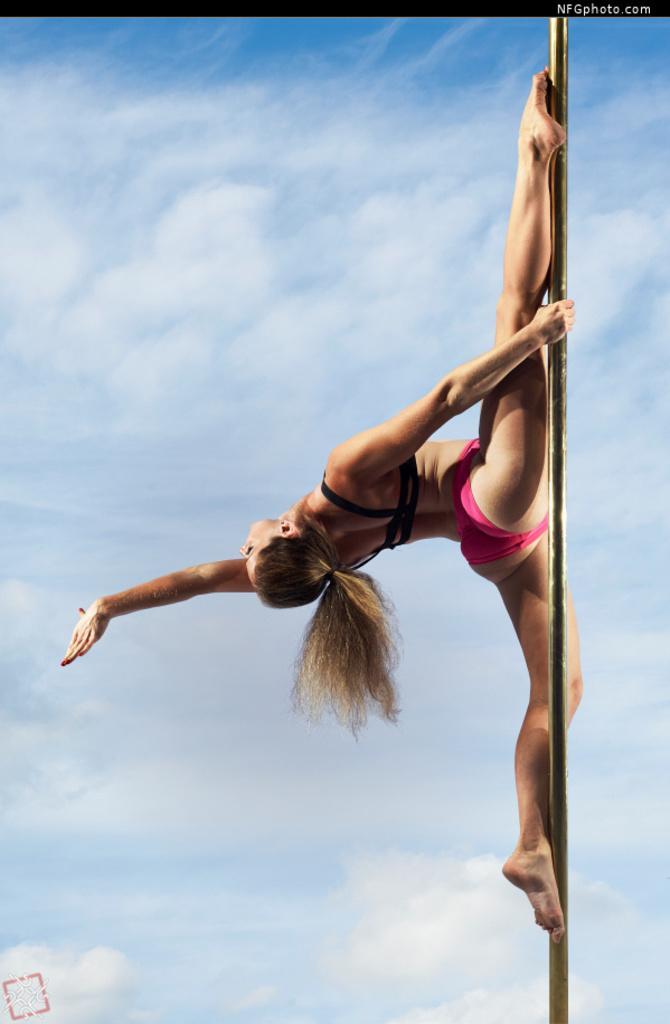Can you describe this image briefly? In this image we can see one woman doing pole vault, some text on this image and background there is the sky. 